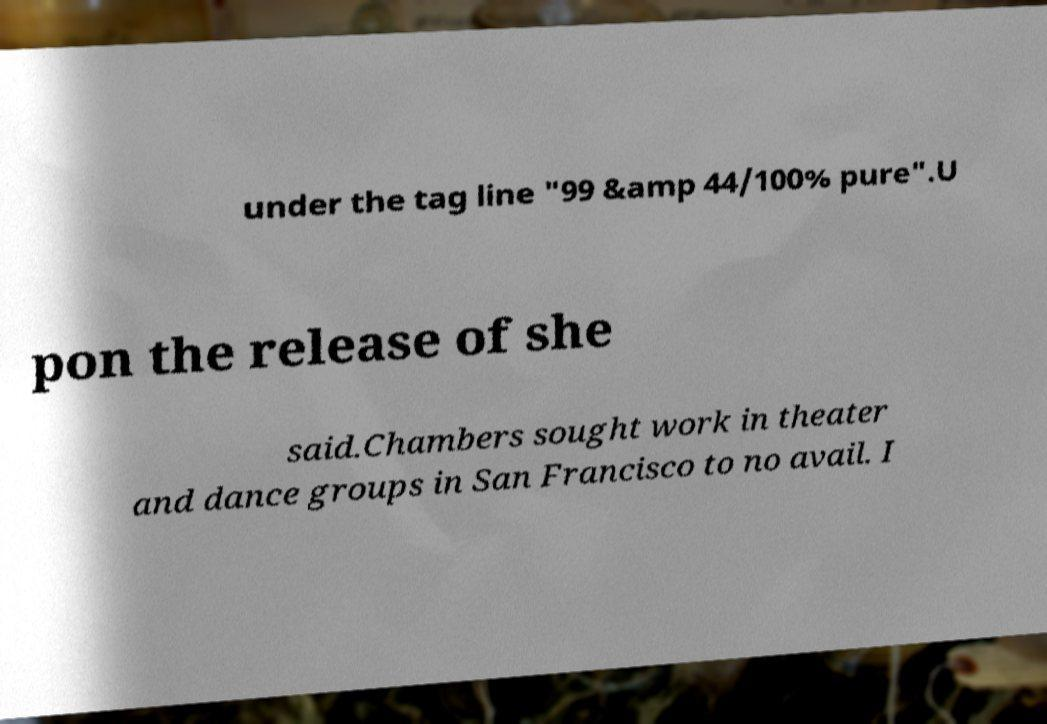I need the written content from this picture converted into text. Can you do that? under the tag line "99 &amp 44/100% pure".U pon the release of she said.Chambers sought work in theater and dance groups in San Francisco to no avail. I 